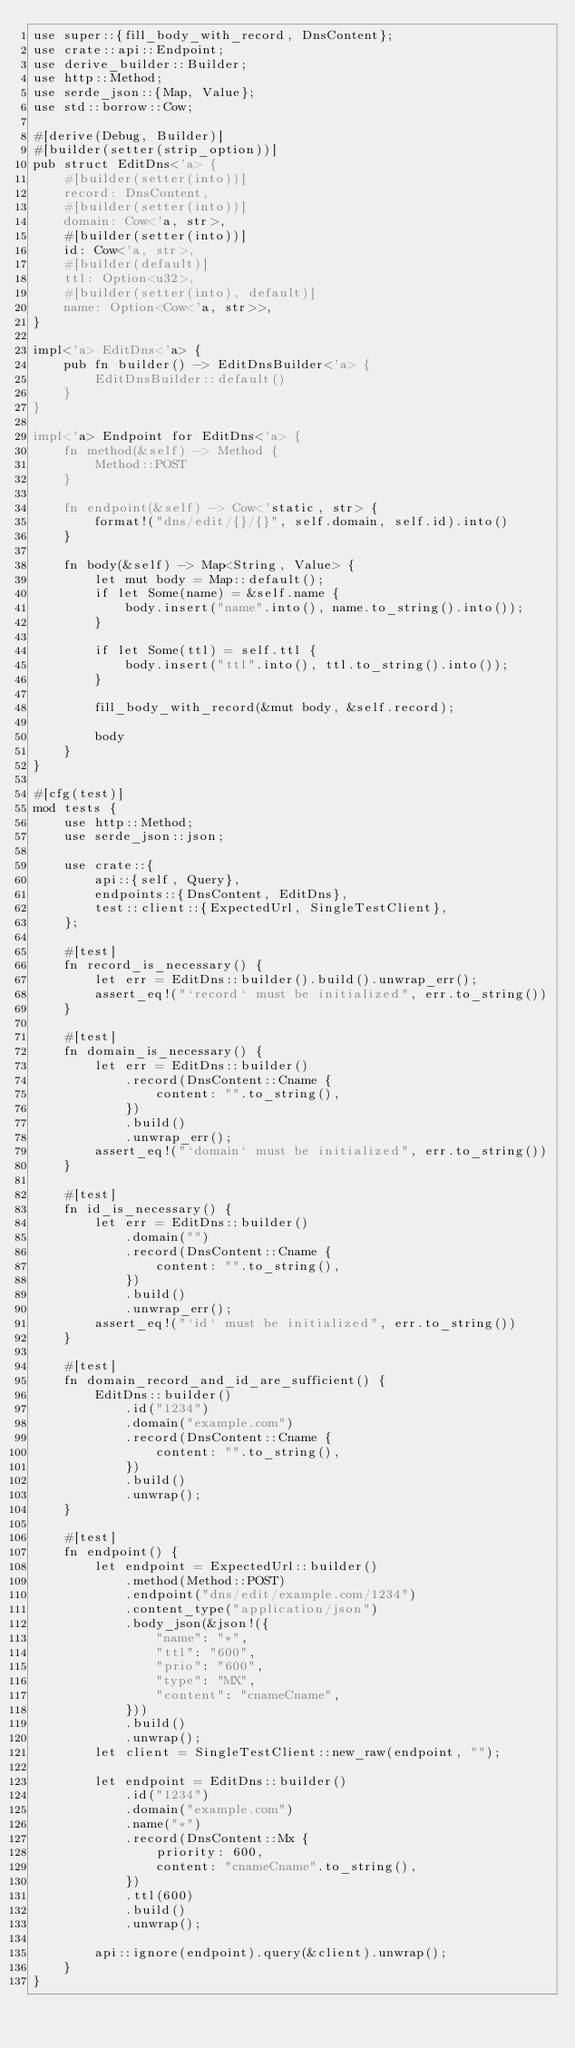<code> <loc_0><loc_0><loc_500><loc_500><_Rust_>use super::{fill_body_with_record, DnsContent};
use crate::api::Endpoint;
use derive_builder::Builder;
use http::Method;
use serde_json::{Map, Value};
use std::borrow::Cow;

#[derive(Debug, Builder)]
#[builder(setter(strip_option))]
pub struct EditDns<'a> {
    #[builder(setter(into))]
    record: DnsContent,
    #[builder(setter(into))]
    domain: Cow<'a, str>,
    #[builder(setter(into))]
    id: Cow<'a, str>,
    #[builder(default)]
    ttl: Option<u32>,
    #[builder(setter(into), default)]
    name: Option<Cow<'a, str>>,
}

impl<'a> EditDns<'a> {
    pub fn builder() -> EditDnsBuilder<'a> {
        EditDnsBuilder::default()
    }
}

impl<'a> Endpoint for EditDns<'a> {
    fn method(&self) -> Method {
        Method::POST
    }

    fn endpoint(&self) -> Cow<'static, str> {
        format!("dns/edit/{}/{}", self.domain, self.id).into()
    }

    fn body(&self) -> Map<String, Value> {
        let mut body = Map::default();
        if let Some(name) = &self.name {
            body.insert("name".into(), name.to_string().into());
        }

        if let Some(ttl) = self.ttl {
            body.insert("ttl".into(), ttl.to_string().into());
        }

        fill_body_with_record(&mut body, &self.record);

        body
    }
}

#[cfg(test)]
mod tests {
    use http::Method;
    use serde_json::json;

    use crate::{
        api::{self, Query},
        endpoints::{DnsContent, EditDns},
        test::client::{ExpectedUrl, SingleTestClient},
    };

    #[test]
    fn record_is_necessary() {
        let err = EditDns::builder().build().unwrap_err();
        assert_eq!("`record` must be initialized", err.to_string())
    }

    #[test]
    fn domain_is_necessary() {
        let err = EditDns::builder()
            .record(DnsContent::Cname {
                content: "".to_string(),
            })
            .build()
            .unwrap_err();
        assert_eq!("`domain` must be initialized", err.to_string())
    }

    #[test]
    fn id_is_necessary() {
        let err = EditDns::builder()
            .domain("")
            .record(DnsContent::Cname {
                content: "".to_string(),
            })
            .build()
            .unwrap_err();
        assert_eq!("`id` must be initialized", err.to_string())
    }

    #[test]
    fn domain_record_and_id_are_sufficient() {
        EditDns::builder()
            .id("1234")
            .domain("example.com")
            .record(DnsContent::Cname {
                content: "".to_string(),
            })
            .build()
            .unwrap();
    }

    #[test]
    fn endpoint() {
        let endpoint = ExpectedUrl::builder()
            .method(Method::POST)
            .endpoint("dns/edit/example.com/1234")
            .content_type("application/json")
            .body_json(&json!({
                "name": "*",
                "ttl": "600",
                "prio": "600",
                "type": "MX",
                "content": "cnameCname",
            }))
            .build()
            .unwrap();
        let client = SingleTestClient::new_raw(endpoint, "");

        let endpoint = EditDns::builder()
            .id("1234")
            .domain("example.com")
            .name("*")
            .record(DnsContent::Mx {
                priority: 600,
                content: "cnameCname".to_string(),
            })
            .ttl(600)
            .build()
            .unwrap();

        api::ignore(endpoint).query(&client).unwrap();
    }
}
</code> 